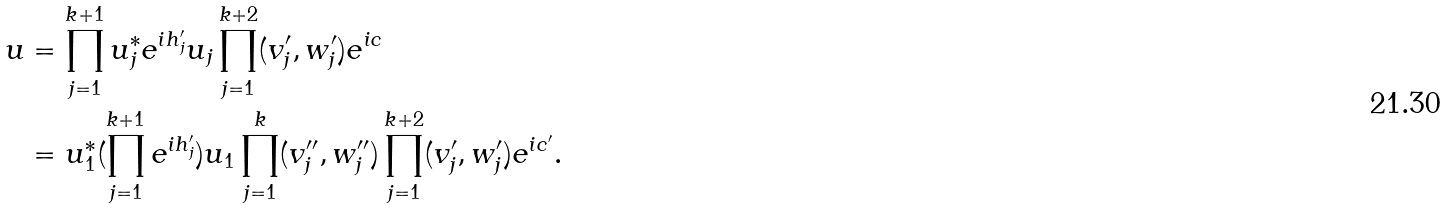Convert formula to latex. <formula><loc_0><loc_0><loc_500><loc_500>u & = \prod _ { j = 1 } ^ { k + 1 } u _ { j } ^ { * } e ^ { i h _ { j } ^ { \prime } } u _ { j } \prod _ { j = 1 } ^ { k + 2 } ( v _ { j } ^ { \prime } , w _ { j } ^ { \prime } ) e ^ { i c } \\ & = u _ { 1 } ^ { * } ( \prod _ { j = 1 } ^ { k + 1 } e ^ { i h _ { j } ^ { \prime } } ) u _ { 1 } \prod _ { j = 1 } ^ { k } ( v _ { j } ^ { \prime \prime } , w _ { j } ^ { \prime \prime } ) \prod _ { j = 1 } ^ { k + 2 } ( v _ { j } ^ { \prime } , w _ { j } ^ { \prime } ) e ^ { i c ^ { \prime } } .</formula> 